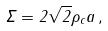Convert formula to latex. <formula><loc_0><loc_0><loc_500><loc_500>\Sigma = 2 \sqrt { 2 } \rho _ { c } a \, ,</formula> 